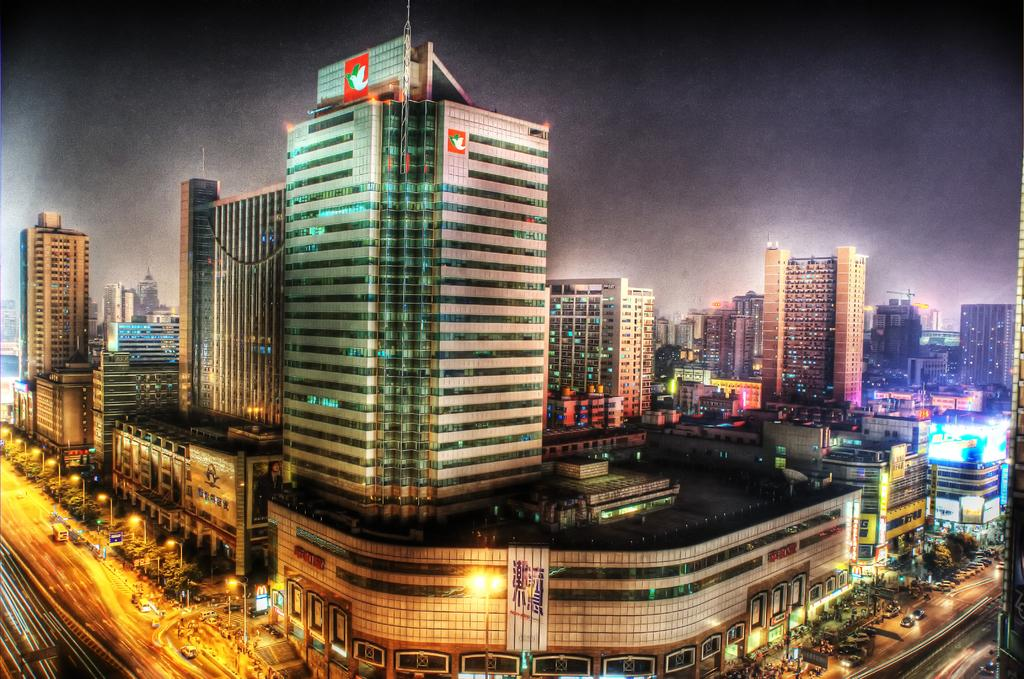What is located in the center of the image? There are buildings in the center of the image. What is at the bottom of the image? There is a road at the bottom of the image. What can be seen at the top of the image? The sky is visible at the top of the image. What language is spoken by the baby playing basketball in the image? There is no baby or basketball present in the image. What type of language is used in the buildings in the image? The image does not provide information about the language spoken or used in the buildings. 